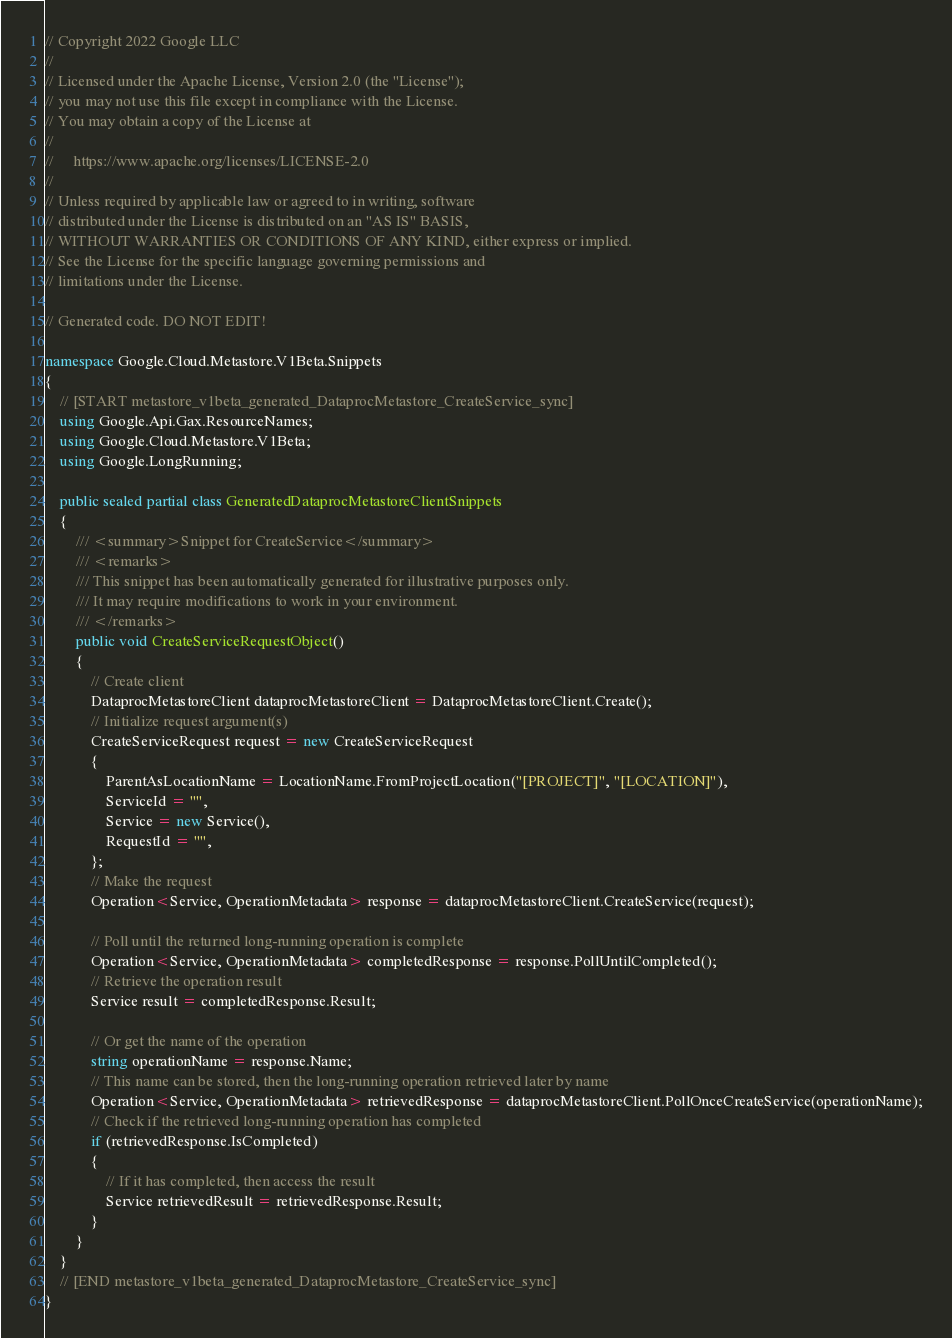Convert code to text. <code><loc_0><loc_0><loc_500><loc_500><_C#_>// Copyright 2022 Google LLC
//
// Licensed under the Apache License, Version 2.0 (the "License");
// you may not use this file except in compliance with the License.
// You may obtain a copy of the License at
//
//     https://www.apache.org/licenses/LICENSE-2.0
//
// Unless required by applicable law or agreed to in writing, software
// distributed under the License is distributed on an "AS IS" BASIS,
// WITHOUT WARRANTIES OR CONDITIONS OF ANY KIND, either express or implied.
// See the License for the specific language governing permissions and
// limitations under the License.

// Generated code. DO NOT EDIT!

namespace Google.Cloud.Metastore.V1Beta.Snippets
{
    // [START metastore_v1beta_generated_DataprocMetastore_CreateService_sync]
    using Google.Api.Gax.ResourceNames;
    using Google.Cloud.Metastore.V1Beta;
    using Google.LongRunning;

    public sealed partial class GeneratedDataprocMetastoreClientSnippets
    {
        /// <summary>Snippet for CreateService</summary>
        /// <remarks>
        /// This snippet has been automatically generated for illustrative purposes only.
        /// It may require modifications to work in your environment.
        /// </remarks>
        public void CreateServiceRequestObject()
        {
            // Create client
            DataprocMetastoreClient dataprocMetastoreClient = DataprocMetastoreClient.Create();
            // Initialize request argument(s)
            CreateServiceRequest request = new CreateServiceRequest
            {
                ParentAsLocationName = LocationName.FromProjectLocation("[PROJECT]", "[LOCATION]"),
                ServiceId = "",
                Service = new Service(),
                RequestId = "",
            };
            // Make the request
            Operation<Service, OperationMetadata> response = dataprocMetastoreClient.CreateService(request);

            // Poll until the returned long-running operation is complete
            Operation<Service, OperationMetadata> completedResponse = response.PollUntilCompleted();
            // Retrieve the operation result
            Service result = completedResponse.Result;

            // Or get the name of the operation
            string operationName = response.Name;
            // This name can be stored, then the long-running operation retrieved later by name
            Operation<Service, OperationMetadata> retrievedResponse = dataprocMetastoreClient.PollOnceCreateService(operationName);
            // Check if the retrieved long-running operation has completed
            if (retrievedResponse.IsCompleted)
            {
                // If it has completed, then access the result
                Service retrievedResult = retrievedResponse.Result;
            }
        }
    }
    // [END metastore_v1beta_generated_DataprocMetastore_CreateService_sync]
}
</code> 